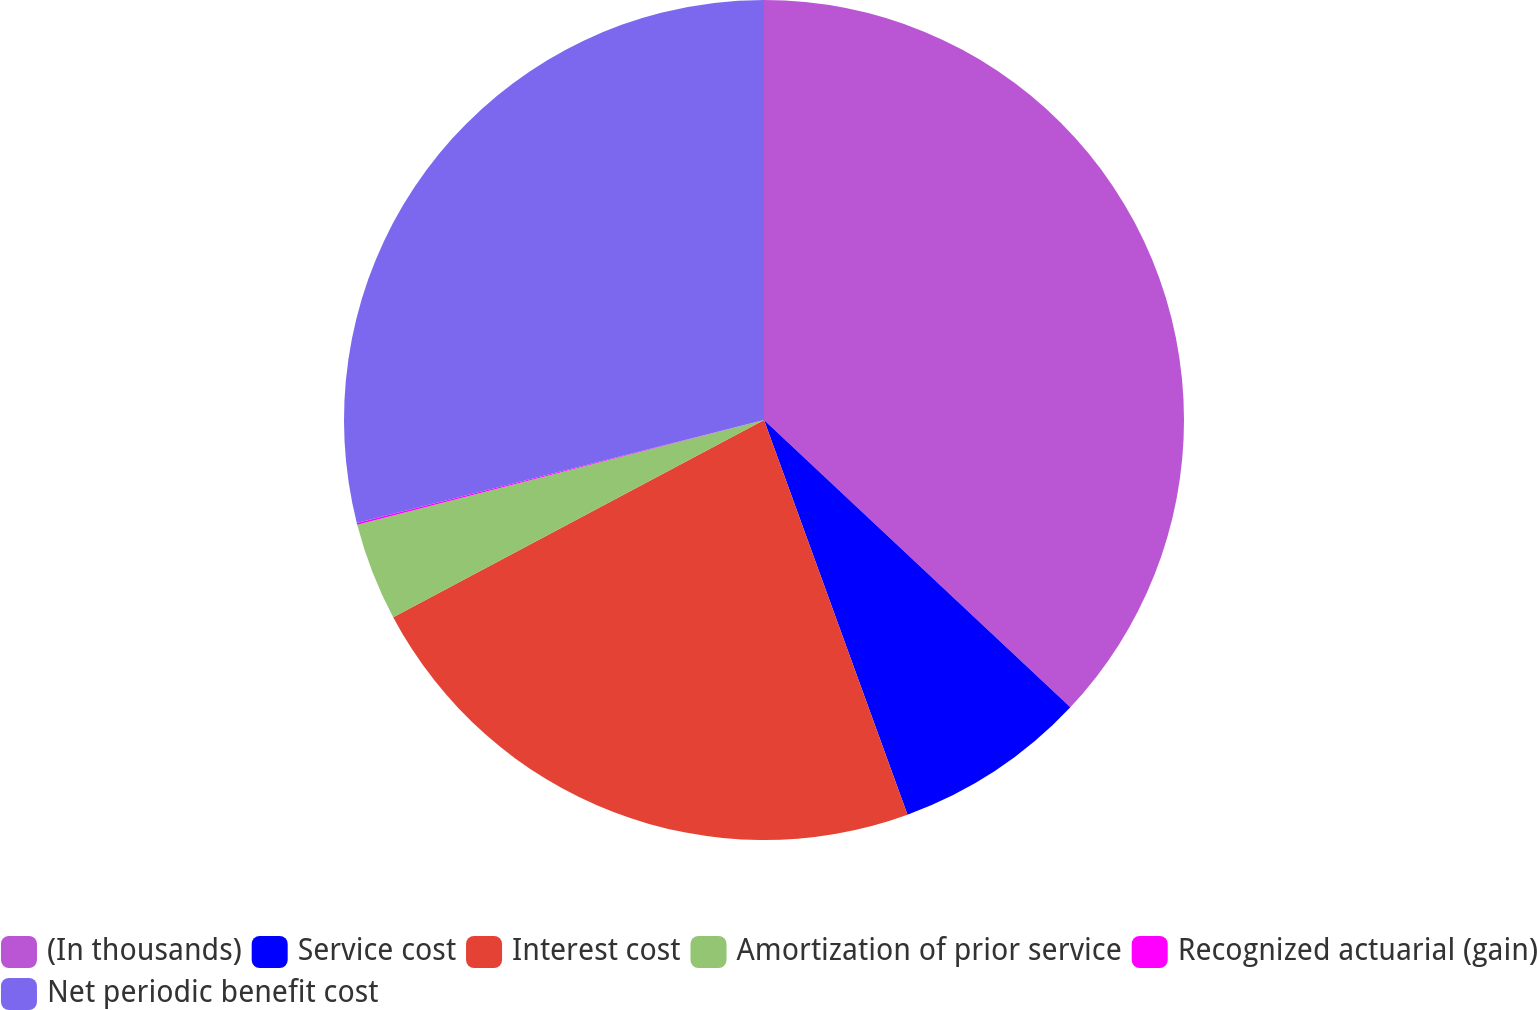Convert chart. <chart><loc_0><loc_0><loc_500><loc_500><pie_chart><fcel>(In thousands)<fcel>Service cost<fcel>Interest cost<fcel>Amortization of prior service<fcel>Recognized actuarial (gain)<fcel>Net periodic benefit cost<nl><fcel>36.99%<fcel>7.46%<fcel>22.77%<fcel>3.77%<fcel>0.07%<fcel>28.94%<nl></chart> 